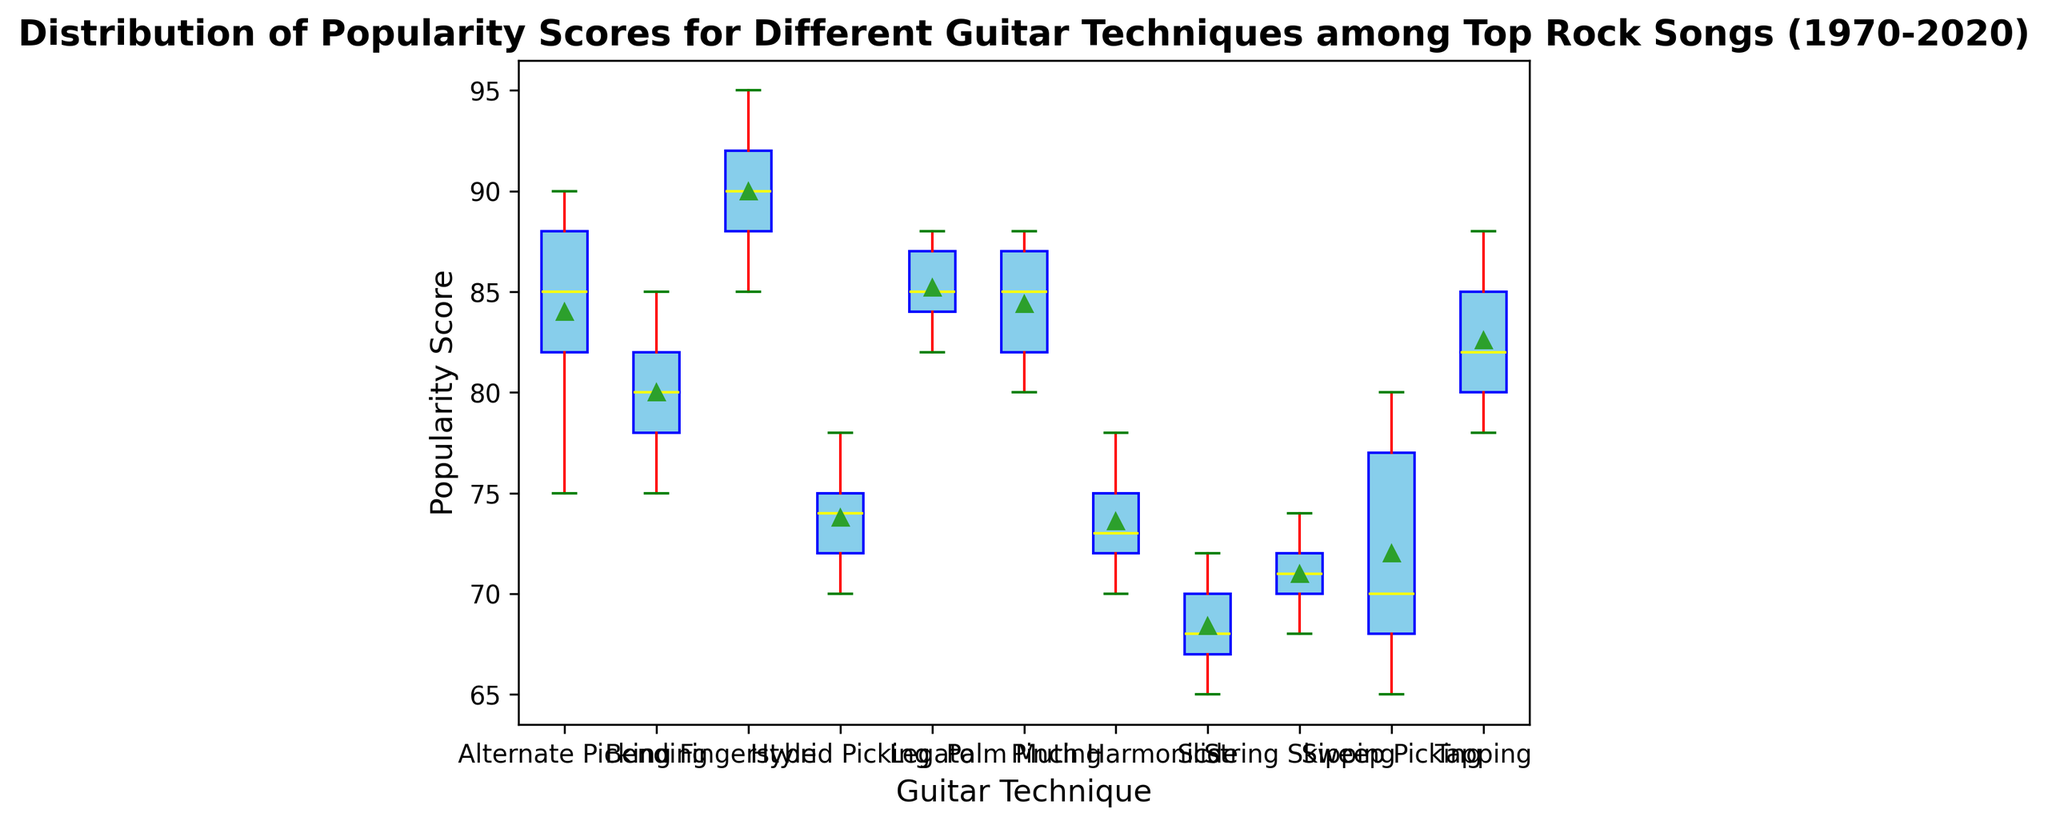What is the median Popularity Score for the Fingerstyle technique? The median is the middle value of an ordered list of values. For Fingerstyle, the scores are [85, 88, 90, 92, 95]. The middle value is 90.
Answer: 90 Which technique has the highest median Popularity Score? By comparing the medians of all techniques, Fingerstyle has the highest median at 90.
Answer: Fingerstyle How do the median Popularity Scores of Alternate Picking and Tapping compare? The median for Alternate Picking is in the middle of [75, 82, 85, 88, 90], which is 85. For Tapping, it is 85 (middle of [78, 80, 82, 85, 88]). Both techniques have the same median score.
Answer: They are equal What can be said about the range of Popularity Scores for Sweep Picking? The range is the difference between the maximum and minimum values. For Sweep Picking, the values are [65, 68, 70, 77, 80], so the range is 80 - 65 = 15.
Answer: 15 Which technique has the widest interquartile range (IQR)? The IQR is the difference between the third and first quartiles. By visually inspecting the box plot, Legato has a notably wide box, indicating it likely has the widest IQR.
Answer: Legato How does the maximum Popularity Score of Palm Muting compare to that of Alternate Picking? The maximum score for Palm Muting is around 88-90, while for Alternate Picking is exactly 90. Palm Muting's max is slightly lower.
Answer: Alternate Picking is higher Which technique has the lowest median Popularity Score? By comparing the box plots, Slide has the lowest median score, which appears to be around 68.
Answer: Slide Describe the central tendency of the Hybrid Picking technique based on the plot. The median (central line) is around 74, the whiskers indicate a range from about 70 to 78, and mean (usually marked with a diamond) aligns closely with the median.
Answer: Median around 74, range 70 to 78 Among the listed techniques, which one has the most symmetric distribution of Popularity Scores? Symmetry is indicated by a median line close to the box’s center and equally extending whiskers. Tapping appears most symmetric as its median line is centered and whiskers are balanced.
Answer: Tapping How many techniques have an outlier in their Popularity Score distribution? Identify techniques with points outside the whiskers; only Sweep Picking has noticeable outliers (orange dots).
Answer: One technique 